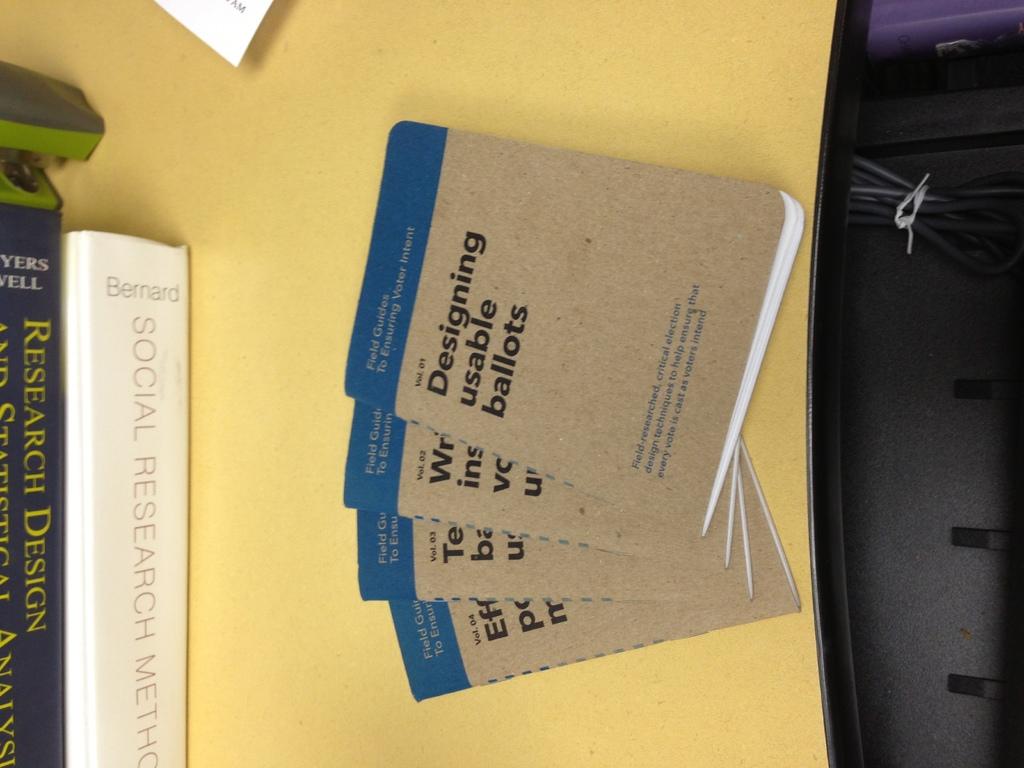What says the book with white cover?
Provide a short and direct response. Social research method. 